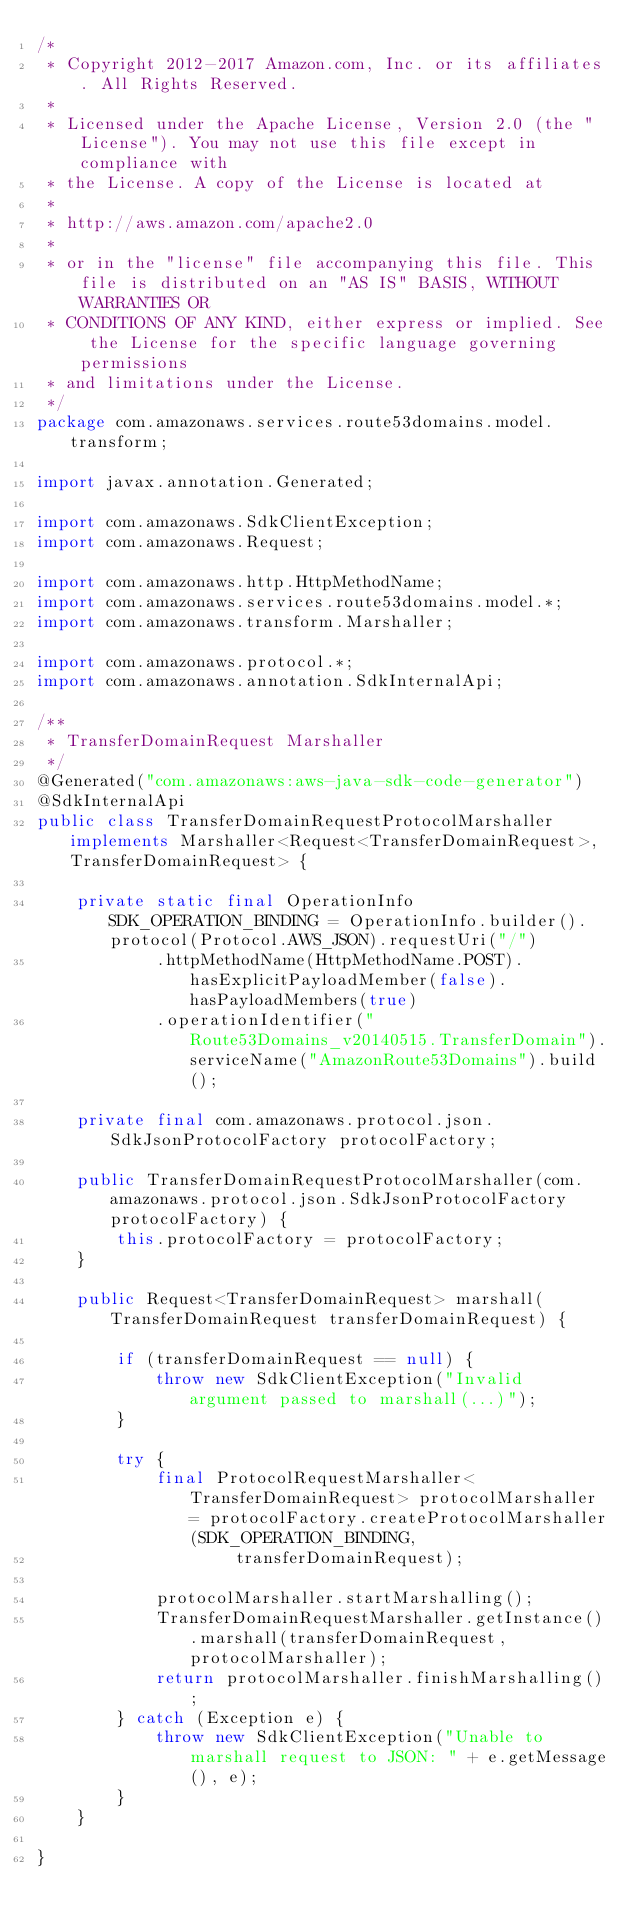<code> <loc_0><loc_0><loc_500><loc_500><_Java_>/*
 * Copyright 2012-2017 Amazon.com, Inc. or its affiliates. All Rights Reserved.
 * 
 * Licensed under the Apache License, Version 2.0 (the "License"). You may not use this file except in compliance with
 * the License. A copy of the License is located at
 * 
 * http://aws.amazon.com/apache2.0
 * 
 * or in the "license" file accompanying this file. This file is distributed on an "AS IS" BASIS, WITHOUT WARRANTIES OR
 * CONDITIONS OF ANY KIND, either express or implied. See the License for the specific language governing permissions
 * and limitations under the License.
 */
package com.amazonaws.services.route53domains.model.transform;

import javax.annotation.Generated;

import com.amazonaws.SdkClientException;
import com.amazonaws.Request;

import com.amazonaws.http.HttpMethodName;
import com.amazonaws.services.route53domains.model.*;
import com.amazonaws.transform.Marshaller;

import com.amazonaws.protocol.*;
import com.amazonaws.annotation.SdkInternalApi;

/**
 * TransferDomainRequest Marshaller
 */
@Generated("com.amazonaws:aws-java-sdk-code-generator")
@SdkInternalApi
public class TransferDomainRequestProtocolMarshaller implements Marshaller<Request<TransferDomainRequest>, TransferDomainRequest> {

    private static final OperationInfo SDK_OPERATION_BINDING = OperationInfo.builder().protocol(Protocol.AWS_JSON).requestUri("/")
            .httpMethodName(HttpMethodName.POST).hasExplicitPayloadMember(false).hasPayloadMembers(true)
            .operationIdentifier("Route53Domains_v20140515.TransferDomain").serviceName("AmazonRoute53Domains").build();

    private final com.amazonaws.protocol.json.SdkJsonProtocolFactory protocolFactory;

    public TransferDomainRequestProtocolMarshaller(com.amazonaws.protocol.json.SdkJsonProtocolFactory protocolFactory) {
        this.protocolFactory = protocolFactory;
    }

    public Request<TransferDomainRequest> marshall(TransferDomainRequest transferDomainRequest) {

        if (transferDomainRequest == null) {
            throw new SdkClientException("Invalid argument passed to marshall(...)");
        }

        try {
            final ProtocolRequestMarshaller<TransferDomainRequest> protocolMarshaller = protocolFactory.createProtocolMarshaller(SDK_OPERATION_BINDING,
                    transferDomainRequest);

            protocolMarshaller.startMarshalling();
            TransferDomainRequestMarshaller.getInstance().marshall(transferDomainRequest, protocolMarshaller);
            return protocolMarshaller.finishMarshalling();
        } catch (Exception e) {
            throw new SdkClientException("Unable to marshall request to JSON: " + e.getMessage(), e);
        }
    }

}
</code> 